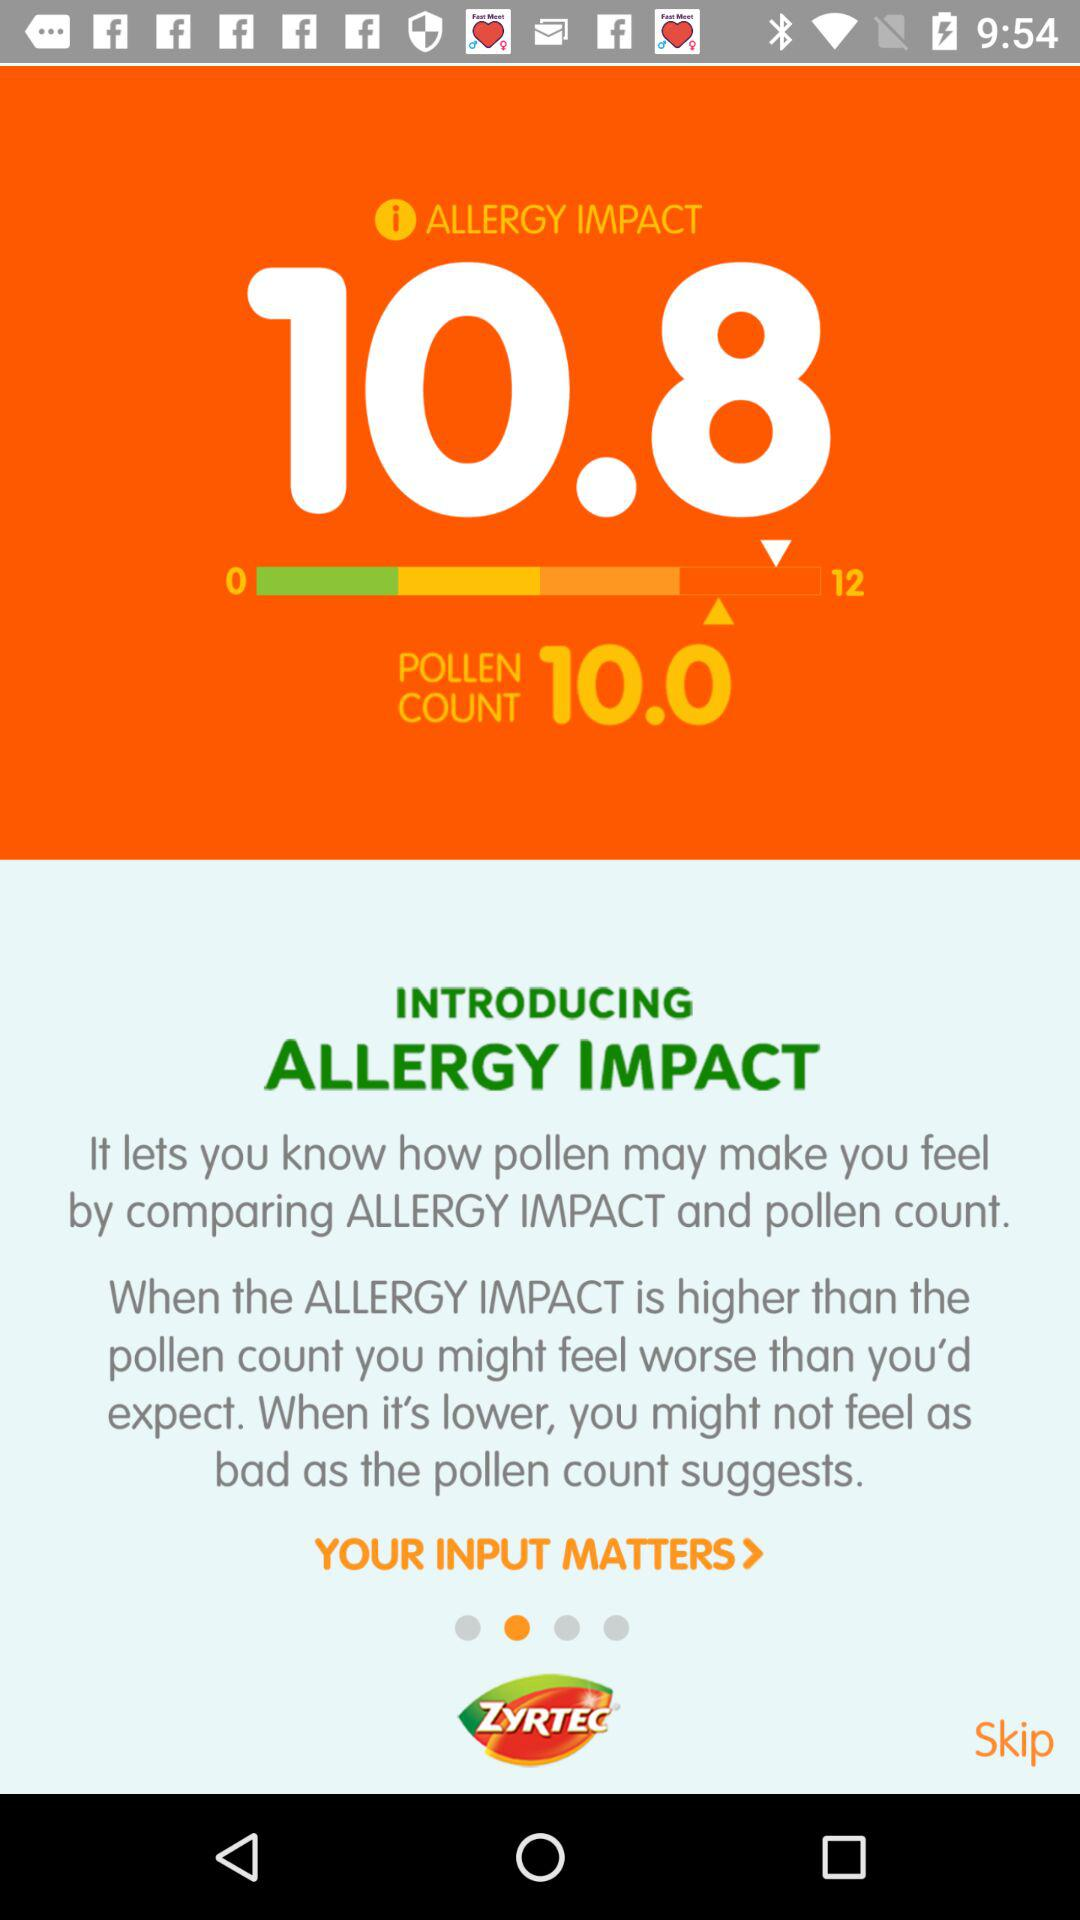What is the allergy impact?
Answer the question using a single word or phrase. The allergy impact is "It lets you know how pollen may make you feel by comparing ALLERGY IMPACT and pollen count. When the ALLERGY IMPACT is higher than the pollen count you might feel worse than you'd expect. When it's lower, you might not feel as bad as the pollen count suggests." 